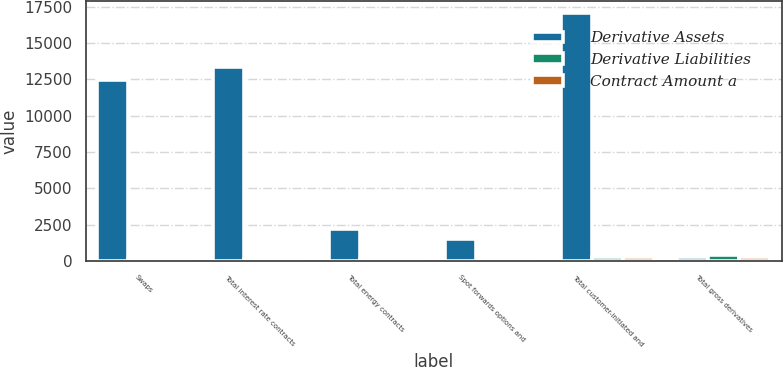Convert chart to OTSL. <chart><loc_0><loc_0><loc_500><loc_500><stacked_bar_chart><ecel><fcel>Swaps<fcel>Total interest rate contracts<fcel>Total energy contracts<fcel>Spot forwards options and<fcel>Total customer-initiated and<fcel>Total gross derivatives<nl><fcel>Derivative Assets<fcel>12451<fcel>13323<fcel>2227<fcel>1509<fcel>17059<fcel>248<nl><fcel>Derivative Liabilities<fcel>130<fcel>131<fcel>146<fcel>36<fcel>313<fcel>407<nl><fcel>Contract Amount a<fcel>76<fcel>77<fcel>144<fcel>27<fcel>248<fcel>254<nl></chart> 